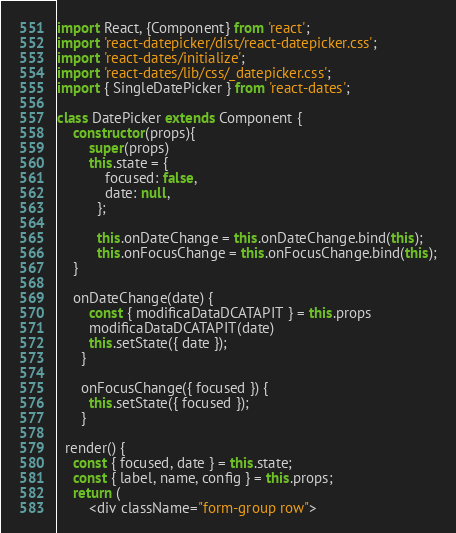<code> <loc_0><loc_0><loc_500><loc_500><_JavaScript_>import React, {Component} from 'react';
import 'react-datepicker/dist/react-datepicker.css';
import 'react-dates/initialize';
import 'react-dates/lib/css/_datepicker.css';
import { SingleDatePicker } from 'react-dates';

class DatePicker extends Component {
    constructor(props){
        super(props)
        this.state = {
            focused: false,
            date: null,
          };
      
          this.onDateChange = this.onDateChange.bind(this);
          this.onFocusChange = this.onFocusChange.bind(this);
    }

    onDateChange(date) {
        const { modificaDataDCATAPIT } = this.props
        modificaDataDCATAPIT(date)
        this.setState({ date });
      }
    
      onFocusChange({ focused }) {
        this.setState({ focused });
      }
    
  render() {
    const { focused, date } = this.state;
    const { label, name, config } = this.props;
    return (
        <div className="form-group row"></code> 